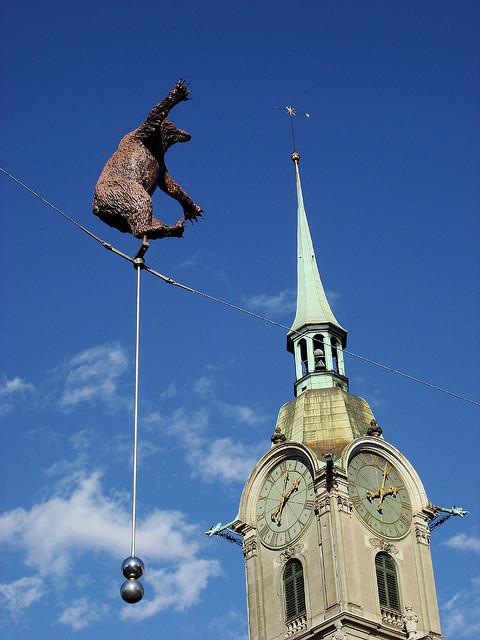In which direction is the bear seen here currently moving? Please explain your reasoning. none. It is not a real bear, and it is not actually moving. it is an art installation that remains in the same place. 